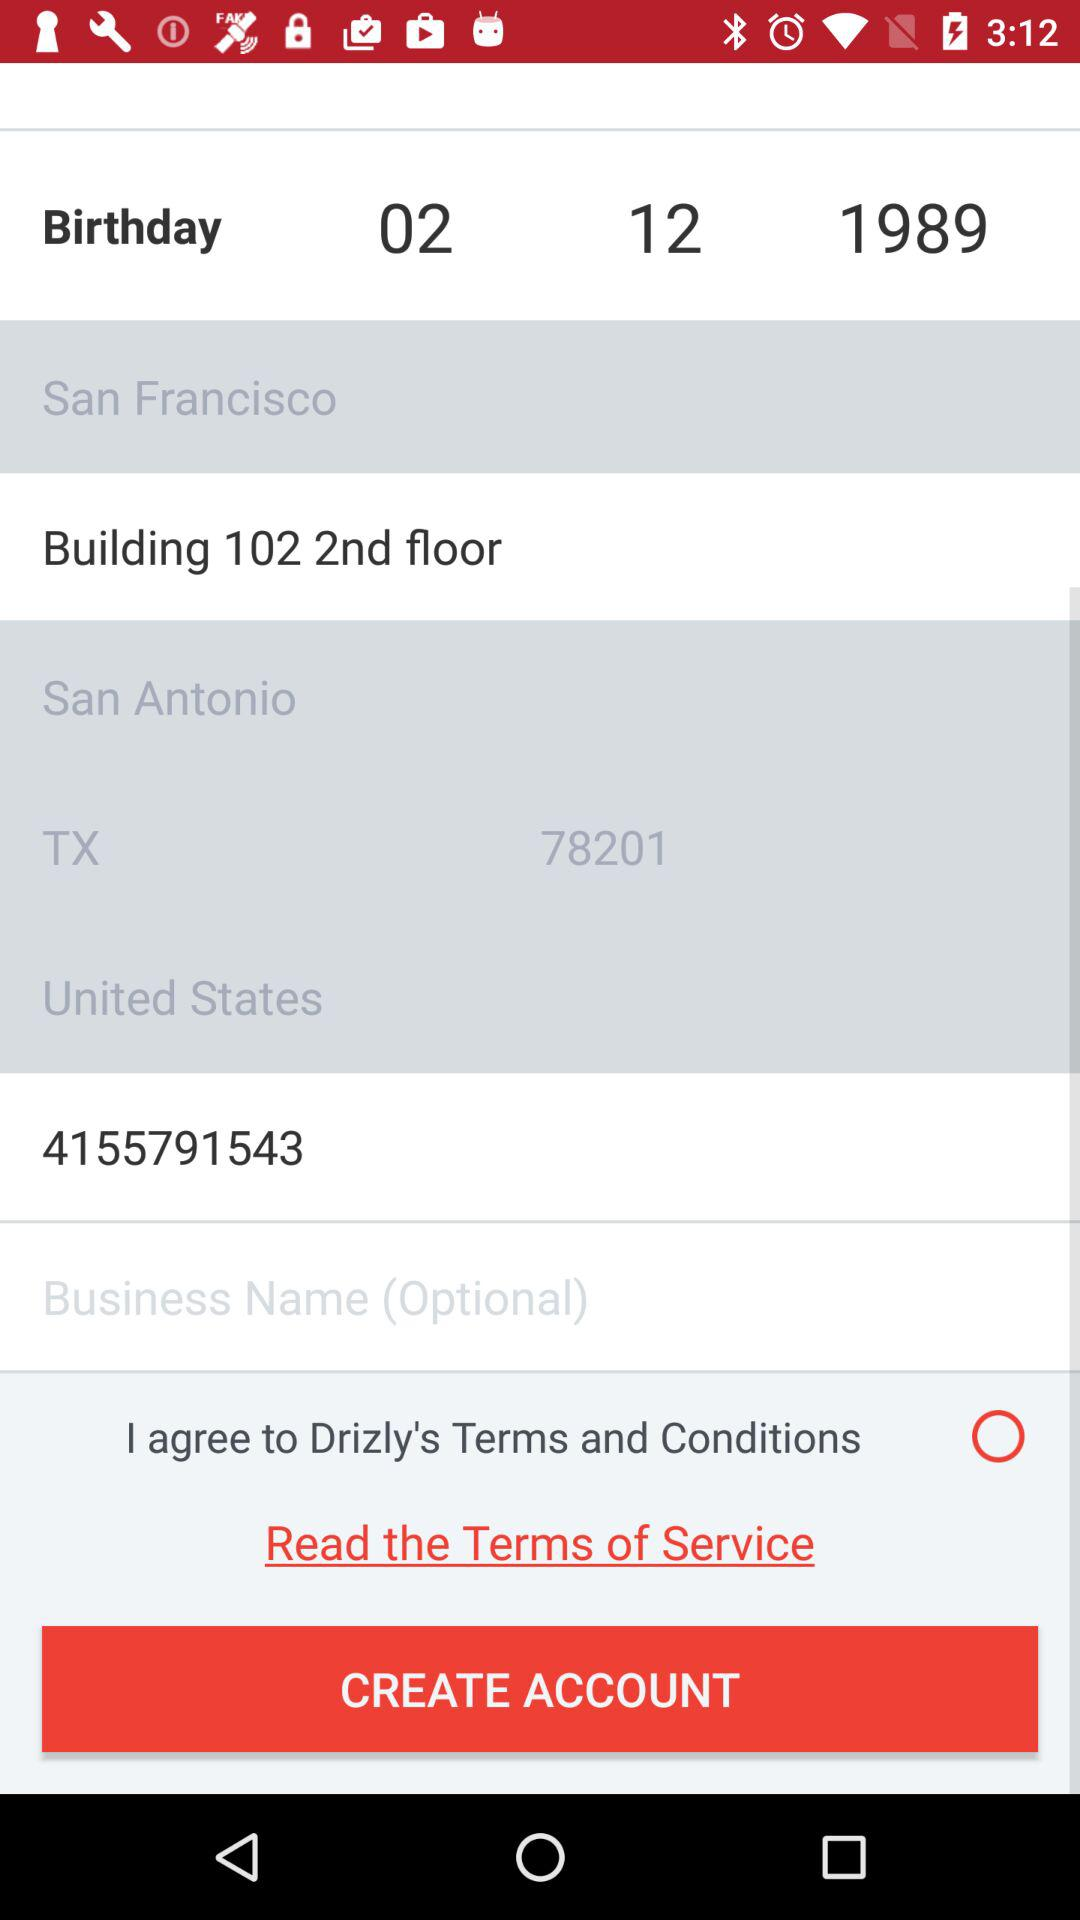What is the country name? The country name is the United States. 